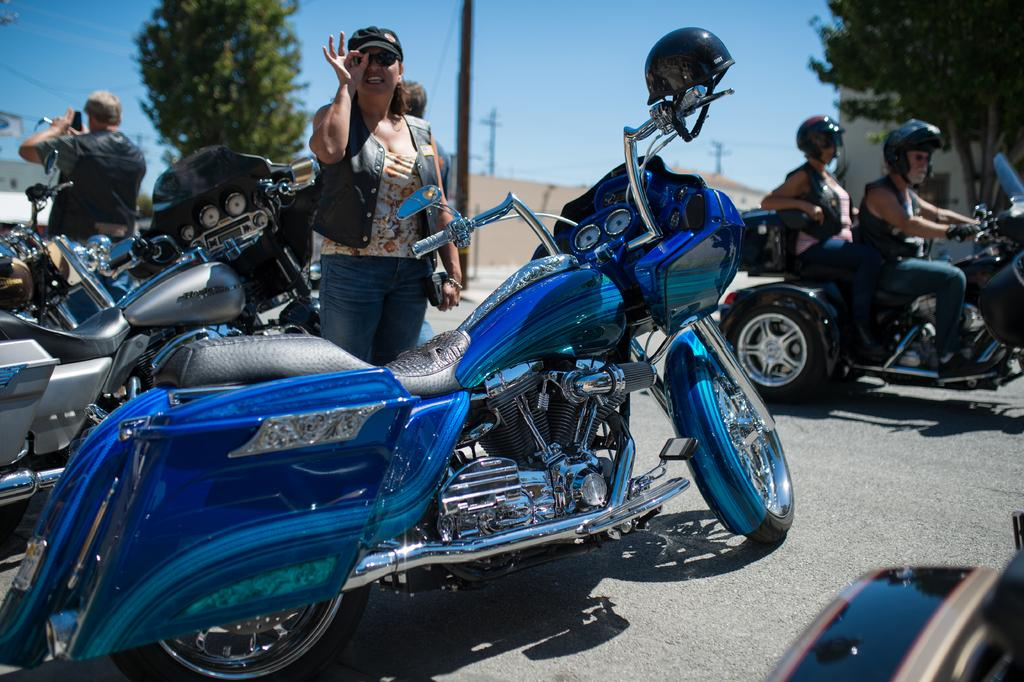What type of vehicles are in the image? There are motorbikes in the image. How many persons are riding on a motorbike? Two persons are sitting on a motorbike. What is the woman wearing in the image? The woman is wearing a cap. What can be seen in the background of the image? Trees are visible in the distance. What is the man holding in the image? The man is standing and holding a mobile. Can you see any wings on the motorbikes in the image? No, there are no wings visible on the motorbikes in the image. What type of cheese is being used as a decoration on the motorbikes? There is no cheese present in the image; it features motorbikes, people, and a mobile. 